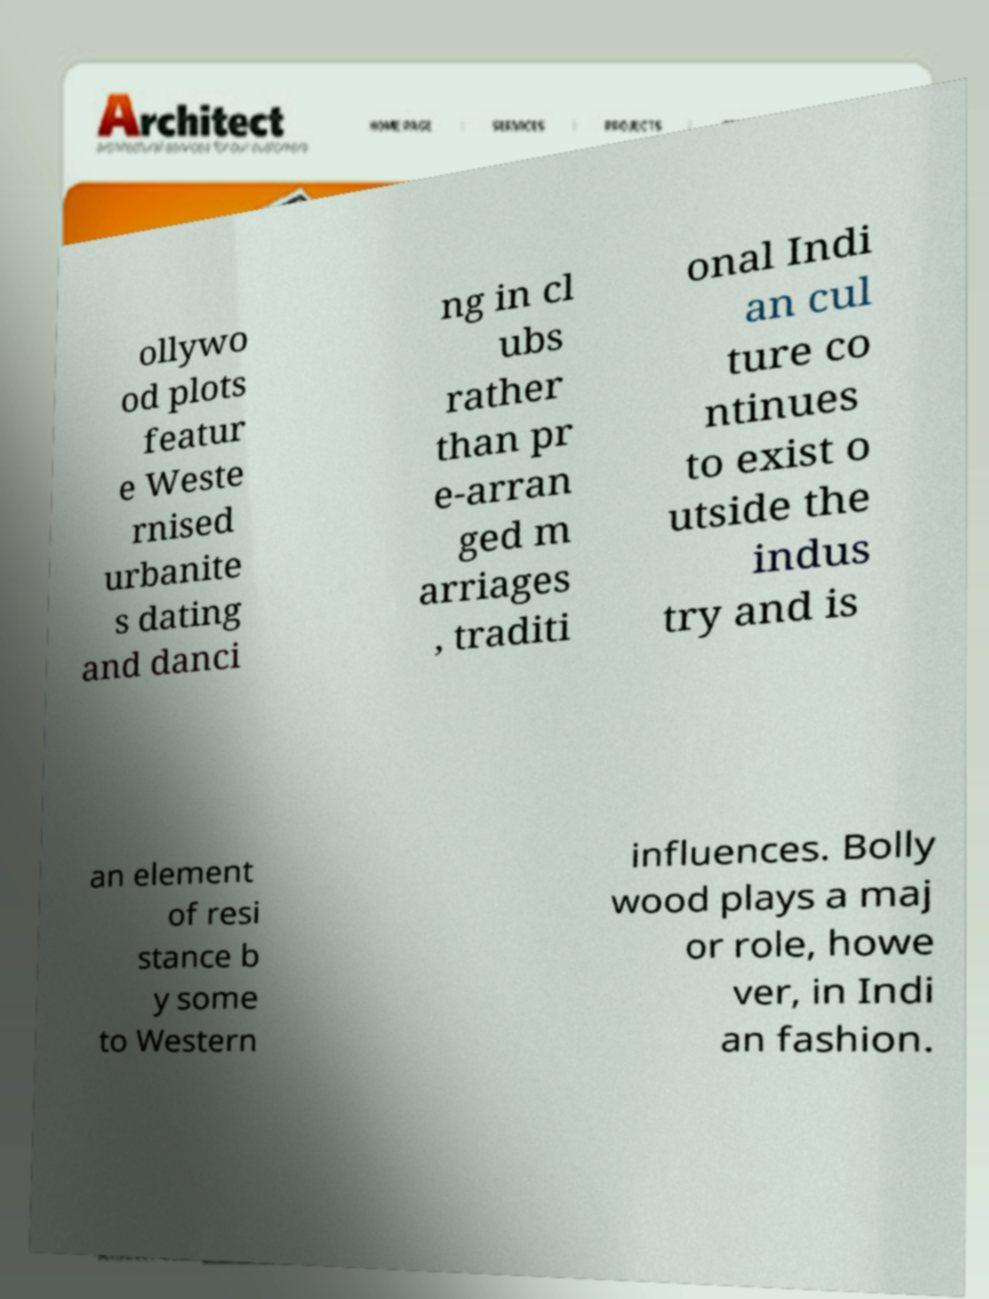Please read and relay the text visible in this image. What does it say? ollywo od plots featur e Weste rnised urbanite s dating and danci ng in cl ubs rather than pr e-arran ged m arriages , traditi onal Indi an cul ture co ntinues to exist o utside the indus try and is an element of resi stance b y some to Western influences. Bolly wood plays a maj or role, howe ver, in Indi an fashion. 